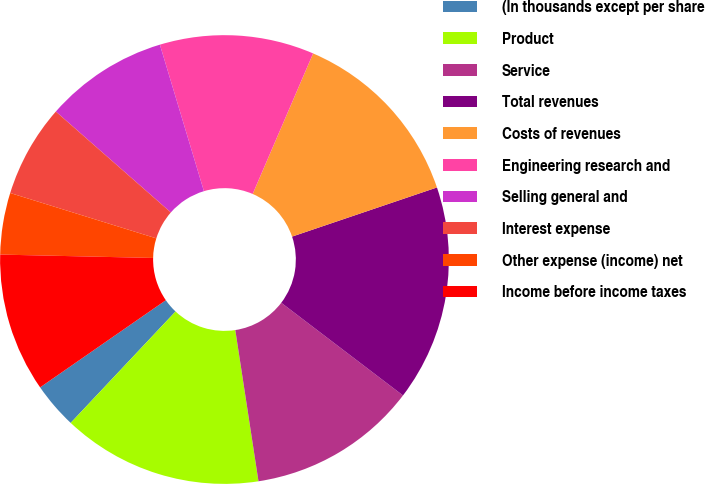Convert chart to OTSL. <chart><loc_0><loc_0><loc_500><loc_500><pie_chart><fcel>(In thousands except per share<fcel>Product<fcel>Service<fcel>Total revenues<fcel>Costs of revenues<fcel>Engineering research and<fcel>Selling general and<fcel>Interest expense<fcel>Other expense (income) net<fcel>Income before income taxes<nl><fcel>3.33%<fcel>14.44%<fcel>12.22%<fcel>15.56%<fcel>13.33%<fcel>11.11%<fcel>8.89%<fcel>6.67%<fcel>4.44%<fcel>10.0%<nl></chart> 